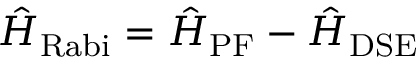Convert formula to latex. <formula><loc_0><loc_0><loc_500><loc_500>\hat { H } _ { R a b i } = \hat { H } _ { P F } - \hat { H } _ { D S E }</formula> 